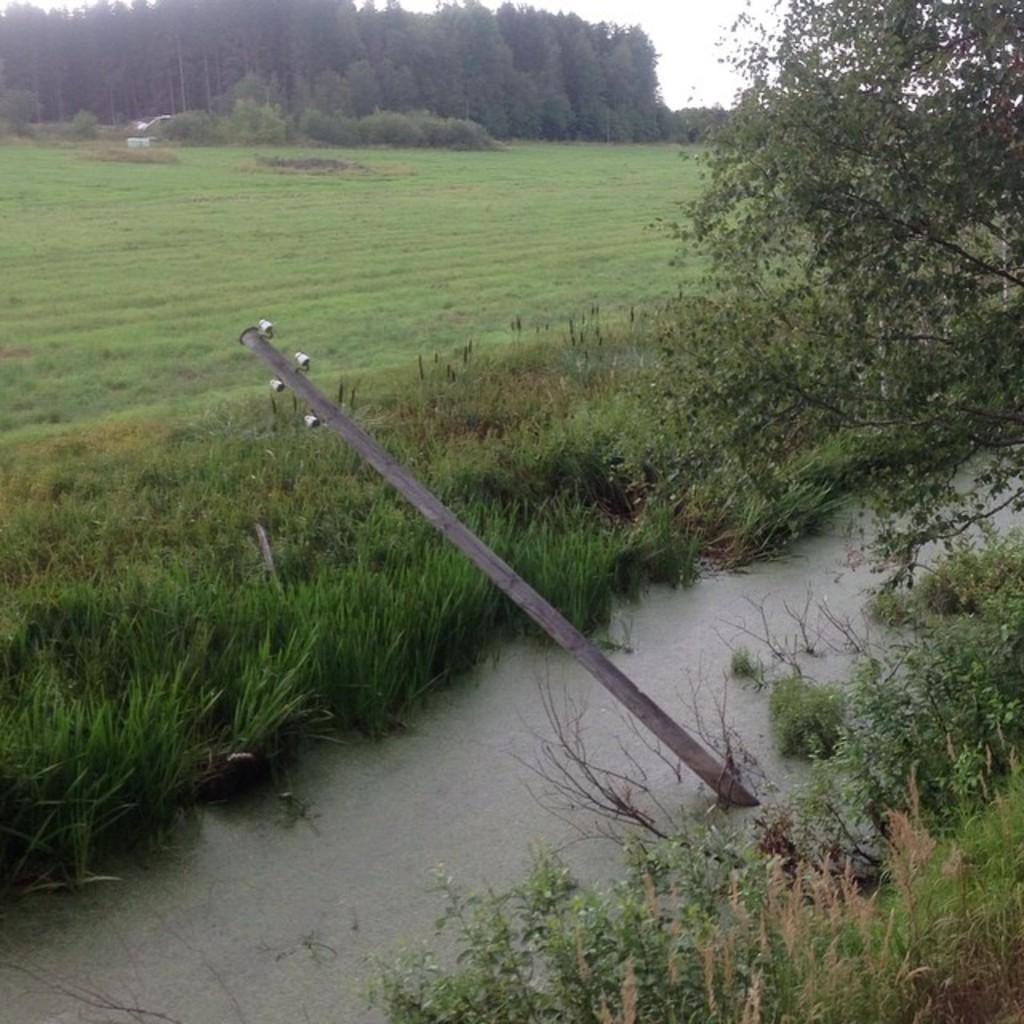Please provide a concise description of this image. In this image there is an electric pole in the water. In the background there are trees. Beside the water there is grass. In the middle there is ground on which there is grass. 